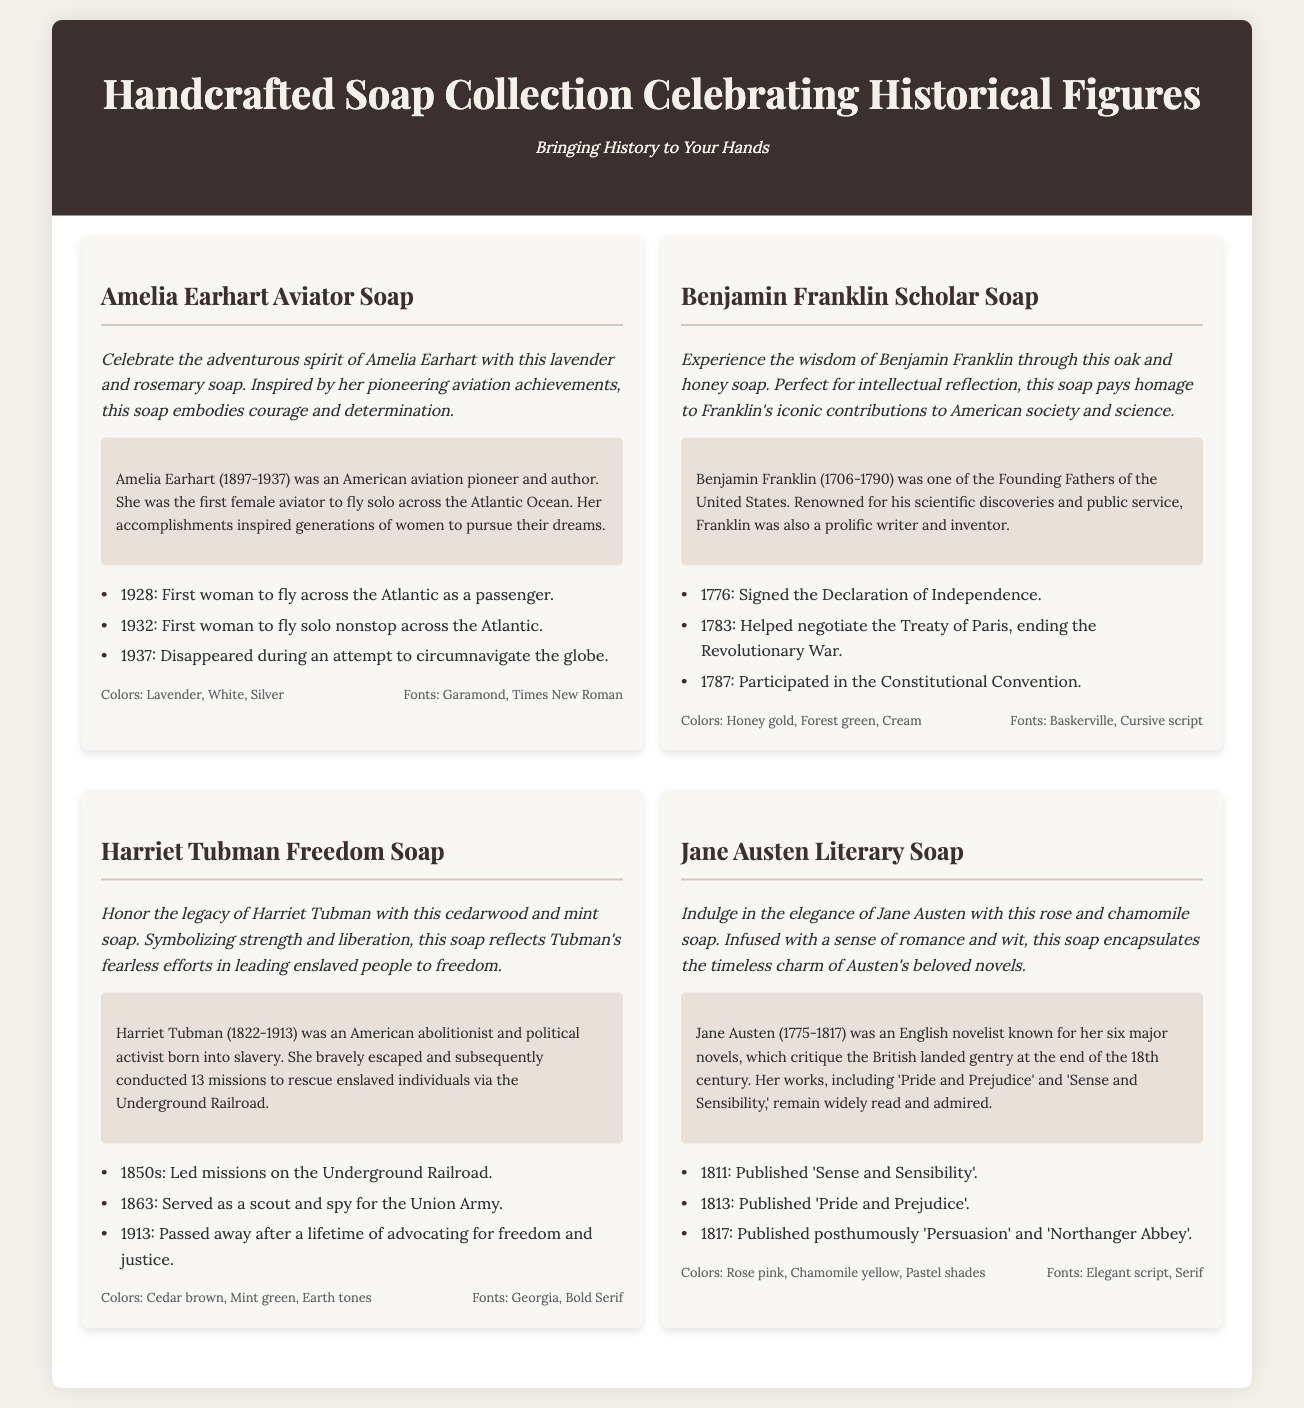What is the name of the soap inspired by an aviator? The document lists "Amelia Earhart Aviator Soap" as inspired by an aviator.
Answer: Amelia Earhart Aviator Soap What fragrance is associated with the Benjamin Franklin soap? The description states that the soap is made with oak and honey, showcasing its fragrance.
Answer: Oak and honey In what year did Harriet Tubman pass away? The document indicates that Harriet Tubman passed away in 1913.
Answer: 1913 Which novel was published first by Jane Austen? The document mentions that "Sense and Sensibility" was published in 1811, making it her first novel.
Answer: Sense and Sensibility What color scheme is used for the Harriet Tubman soap? The design elements specify the colors for the Harriet Tubman soap as cedar brown, mint green, and earth tones.
Answer: Cedar brown, mint green, earth tones How many missions did Harriet Tubman conduct on the Underground Railroad? The document states that she led 13 missions to rescue enslaved individuals via the Underground Railroad.
Answer: 13 missions What notable event occurred in 1776 related to Benjamin Franklin? The document lists that he signed the Declaration of Independence in that year.
Answer: Signed the Declaration of Independence What year was the Amelia Earhart soap inspired by her solo flight? The document notes her solo transatlantic flight took place in 1932.
Answer: 1932 Which historical figure is associated with the soap that reflects strength and liberation? The document describes the Harriet Tubman Freedom Soap as reflecting strength and liberation.
Answer: Harriet Tubman 